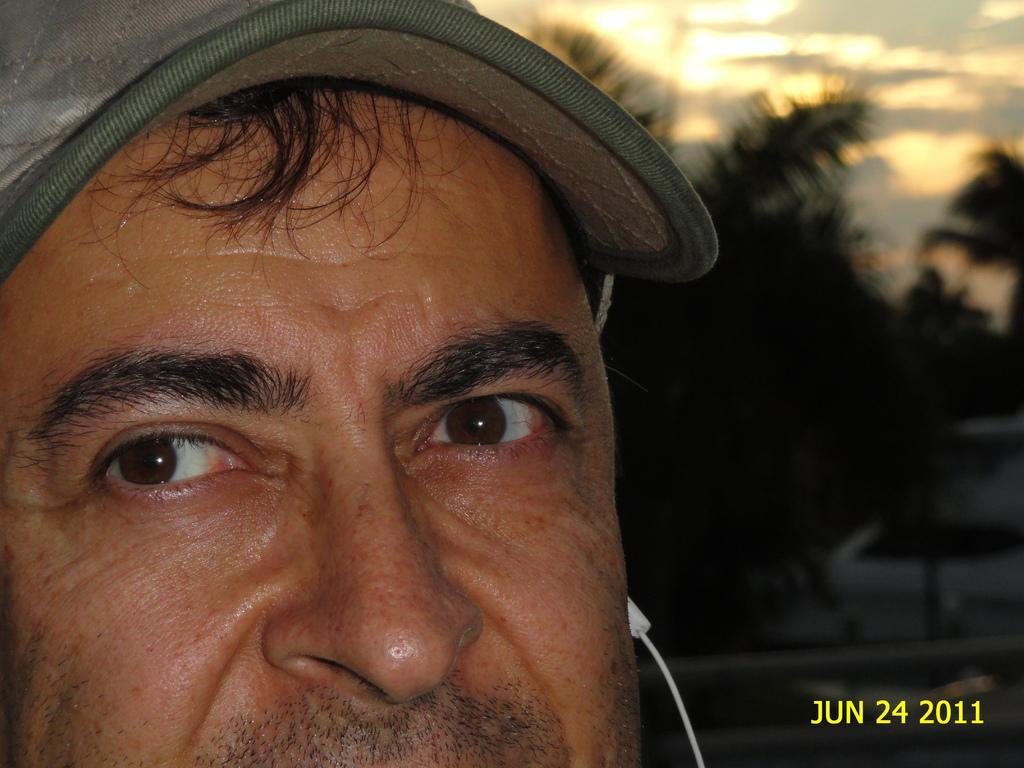How would you summarize this image in a sentence or two? In this image I can see face of a man and I can see he is wearing a cap. I can also see an earphone, a watermark, few trees and I can see this image is little bit blurry from background. 